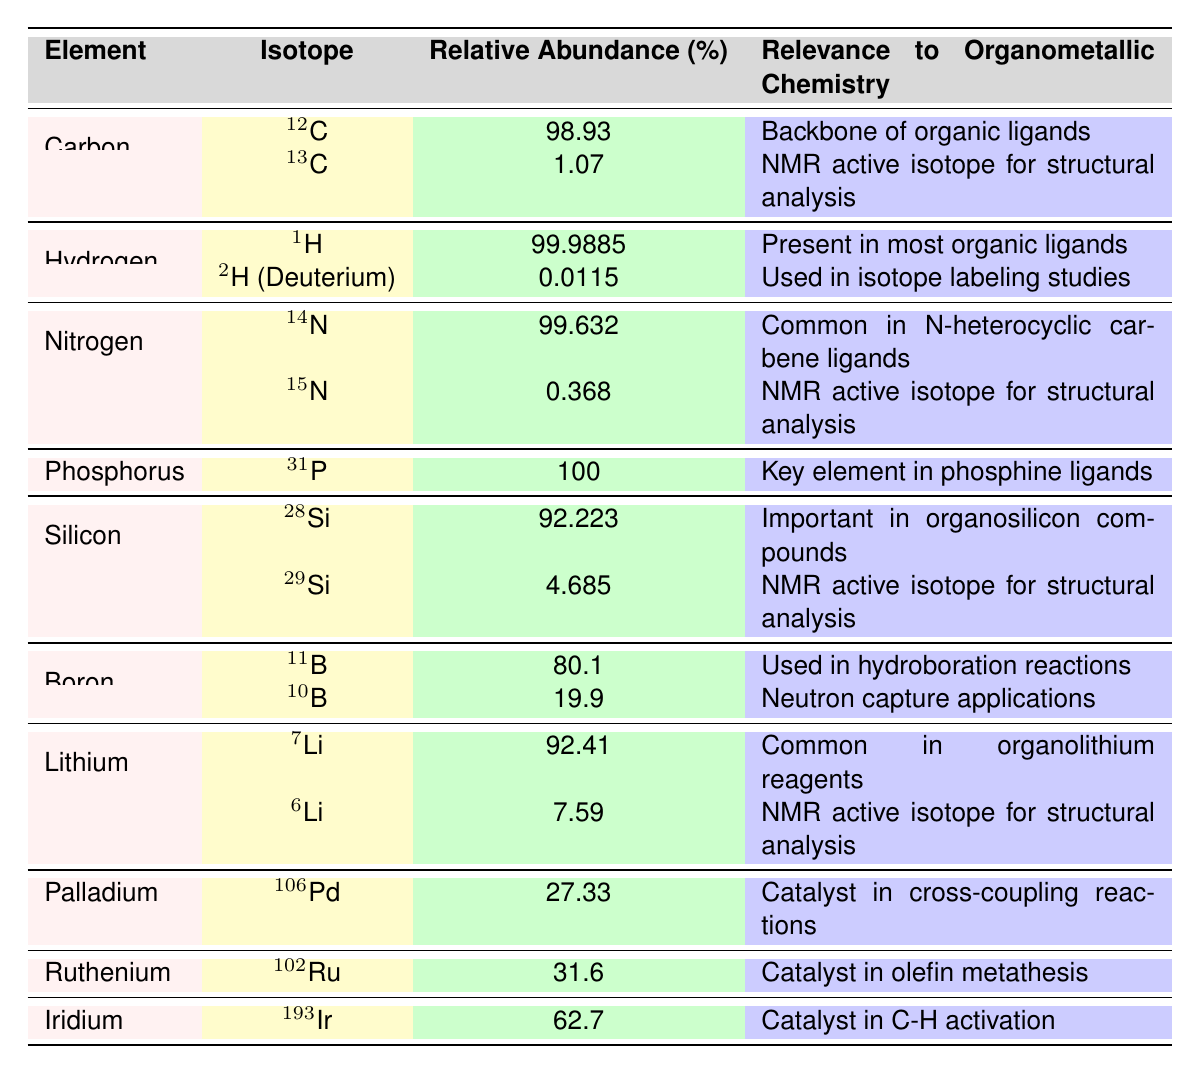What is the relative abundance of Carbon-12? The table shows that the relative abundance of Carbon-12 is listed as 98.93%.
Answer: 98.93% Which isotope of Hydrogen is most abundant? The table indicates that the most abundant isotope of Hydrogen is 1H, with a relative abundance of 99.9885%.
Answer: 1H Is the relative abundance of 10B greater than 50%? The table shows that the relative abundance of 10B is 19.9%, which is not greater than 50%.
Answer: No What is the total relative abundance of Silicon isotopes? The total relative abundance of Silicon isotopes is the sum of 28Si (92.223%) and 29Si (4.685%), giving 92.223 + 4.685 = 96.908%.
Answer: 96.908% Which element has a relative abundance of 100%? The table shows that phosphorus has a relative abundance of 100% for its isotope 31P.
Answer: Phosphorus Are there any Nitrogen isotopes listed that are NMR active? Yes, the table indicates that both 15N and 14N are listed, with 15N being an NMR active isotope for structural analysis.
Answer: Yes What is the difference in relative abundance between 7Li and 6Li? The relative abundance of 7Li is 92.41% and that of 6Li is 7.59%. The difference is calculated as 92.41 - 7.59 = 84.82%.
Answer: 84.82% Which isotope of Boron is used in hydroboration reactions? The table lists 11B as the isotope of Boron used in hydroboration reactions, with a relative abundance of 80.1%.
Answer: 11B How many elements in the table have isotopes with relative abundances less than 5%? From the table, both 2H (Deuterium) (0.0115%) and 15N (0.368%) have relative abundances less than 5%. Thus, there are 2 such elements.
Answer: 2 What is the most relevant isotope for structural analysis among the listed isotopes? The most relevant isotopes for structural analysis are 13C, 15N, 29Si, and 6Li, indicating that these are all NMR active isotopes used for this purpose.
Answer: Multiple isotopes (13C, 15N, 29Si, 6Li) 